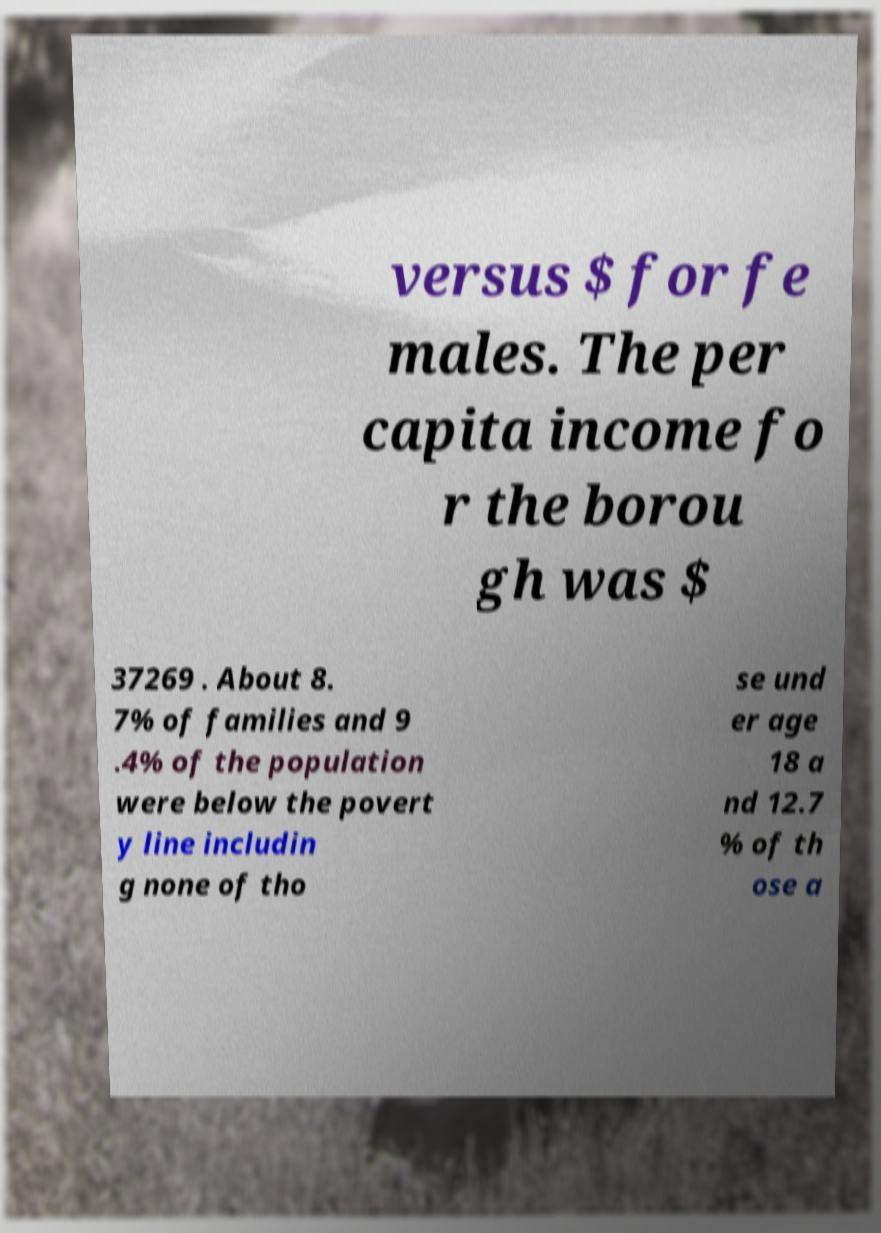Could you assist in decoding the text presented in this image and type it out clearly? versus $ for fe males. The per capita income fo r the borou gh was $ 37269 . About 8. 7% of families and 9 .4% of the population were below the povert y line includin g none of tho se und er age 18 a nd 12.7 % of th ose a 